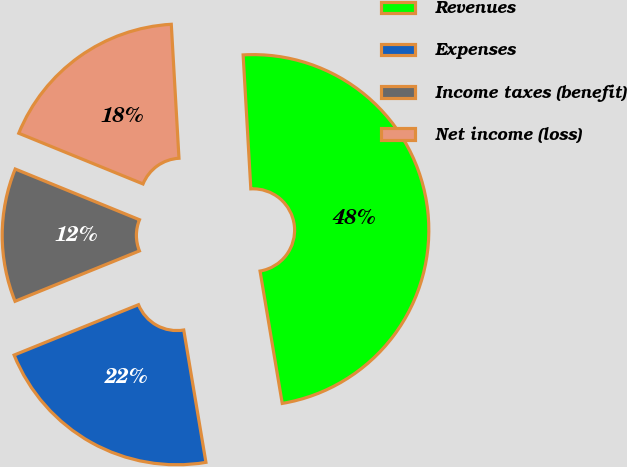<chart> <loc_0><loc_0><loc_500><loc_500><pie_chart><fcel>Revenues<fcel>Expenses<fcel>Income taxes (benefit)<fcel>Net income (loss)<nl><fcel>48.27%<fcel>21.52%<fcel>12.29%<fcel>17.92%<nl></chart> 